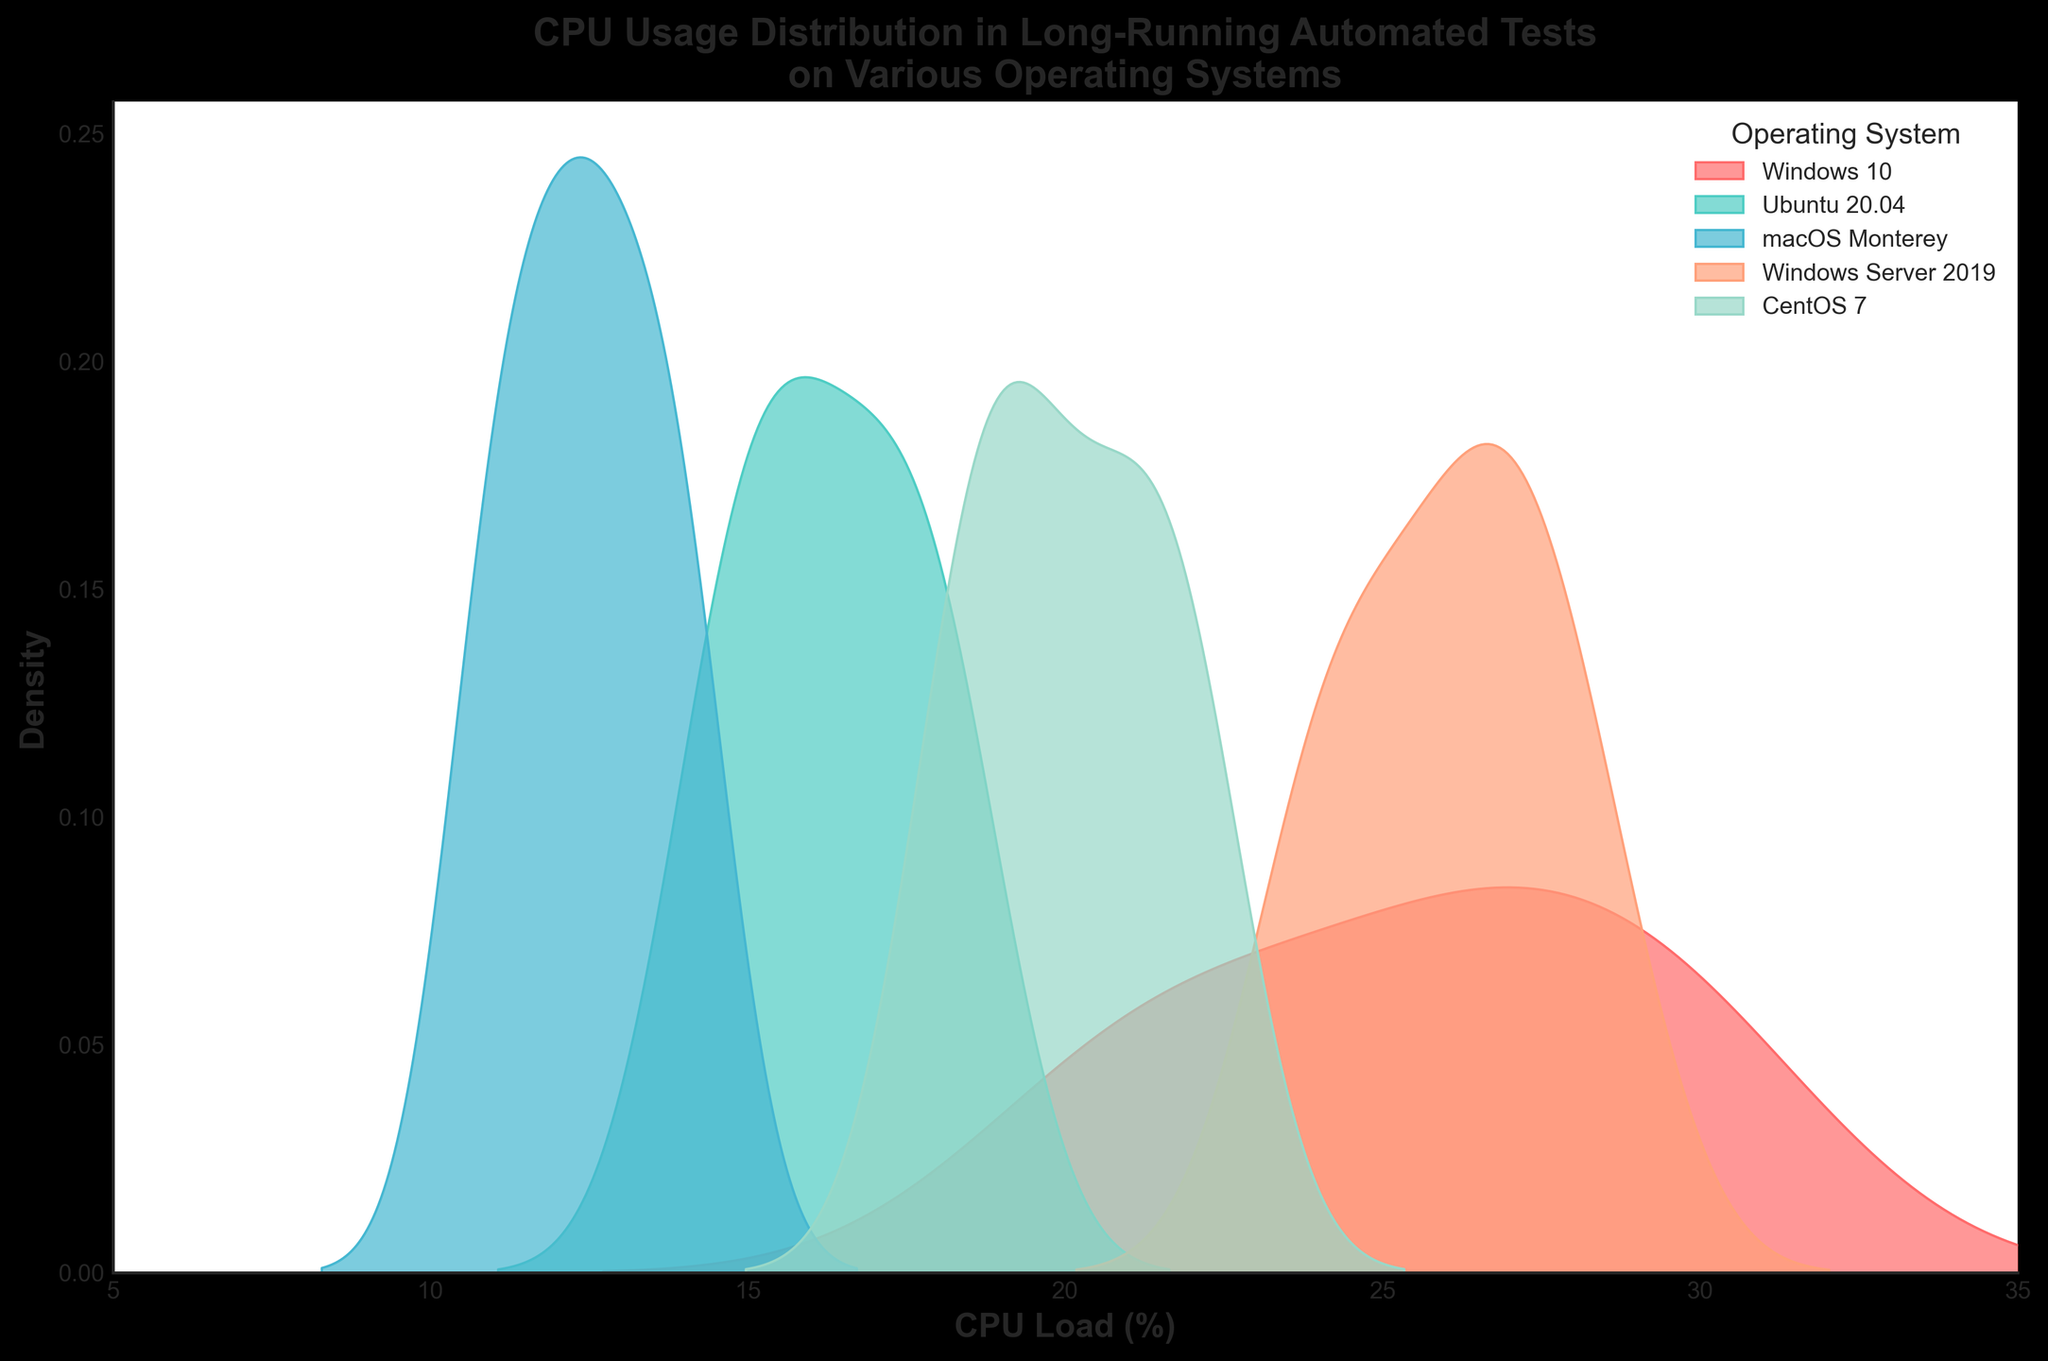What is the title of the plot? The title is usually found at the top of the plot. It provides an overview of what the plot is about. The title here is "CPU Usage Distribution in Long-Running Automated Tests on Various Operating Systems."
Answer: CPU Usage Distribution in Long-Running Automated Tests on Various Operating Systems What does the x-axis represent in the plot? The x-axis is the horizontal axis that displays the range of values measured. In this plot, the x-axis represents "CPU Load (%)".
Answer: CPU Load (%) What does the y-axis represent in the plot? The y-axis is the vertical axis and shows the density in the kernel density estimate plot. It indicates how dense the CPU load values are for particular ranges.
Answer: Density Which operating system has the highest peak density in CPU usage? The peak density is the highest point on the KDE plot for each operating system. By observing the plot, you can see which curve reaches the highest point on the y-axis.
Answer: Windows 10 Which operating system shows the lowest CPU usage density? The lowest CPU usage density is indicated by the operating system with the KDE curve that lies generally lower compared to others across the entire range.
Answer: macOS Monterey How does the density of Windows 10 compare to that of Ubuntu 20.04? Compare the height and spread of the KDE plots for Windows 10 and Ubuntu 20.04. Windows 10 should have a higher peak density and a distinct range of CPU usage.
Answer: Windows 10 has higher density Which operating system has a broader range of CPU loads? The broader range can be determined by looking at the width of the KDE plot for each OS. A wider spread on the KDE plot suggests a broader range of CPU loads.
Answer: Windows Server 2019 What is the approximate CPU load value at which macOS Monterey peaks? The peak CPU load value for macOS Monterey can be observed where its KDE plot reaches the highest point on the x-axis.
Answer: Around 12% Which operating system's CPU usage distribution is closely clustered around 25%? Look for the KDE plot that has its peak and a large part of its density centered around the 25% CPU load mark.
Answer: Windows 10 Which operating system has the least spread in its CPU load distribution? The least spread can be identified by looking at the densest, narrowest KDE plot, suggesting little variation.
Answer: macOS Monterey 